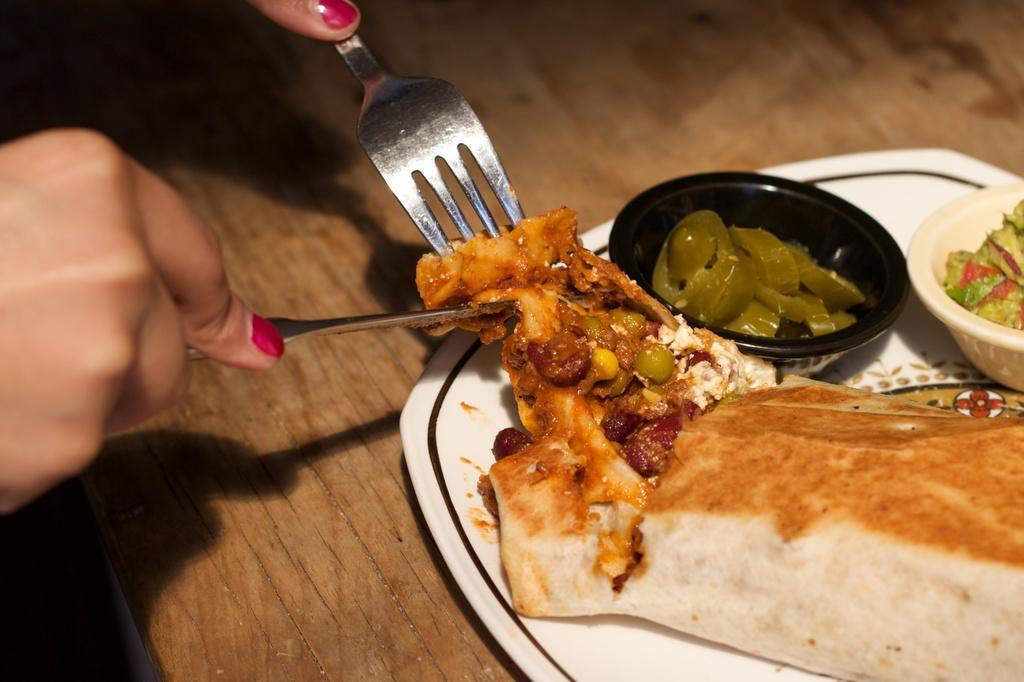Please provide a concise description of this image. In this image I can see food items on a plate which is placed on the table. There are hands of a person holding fork and a knife. 